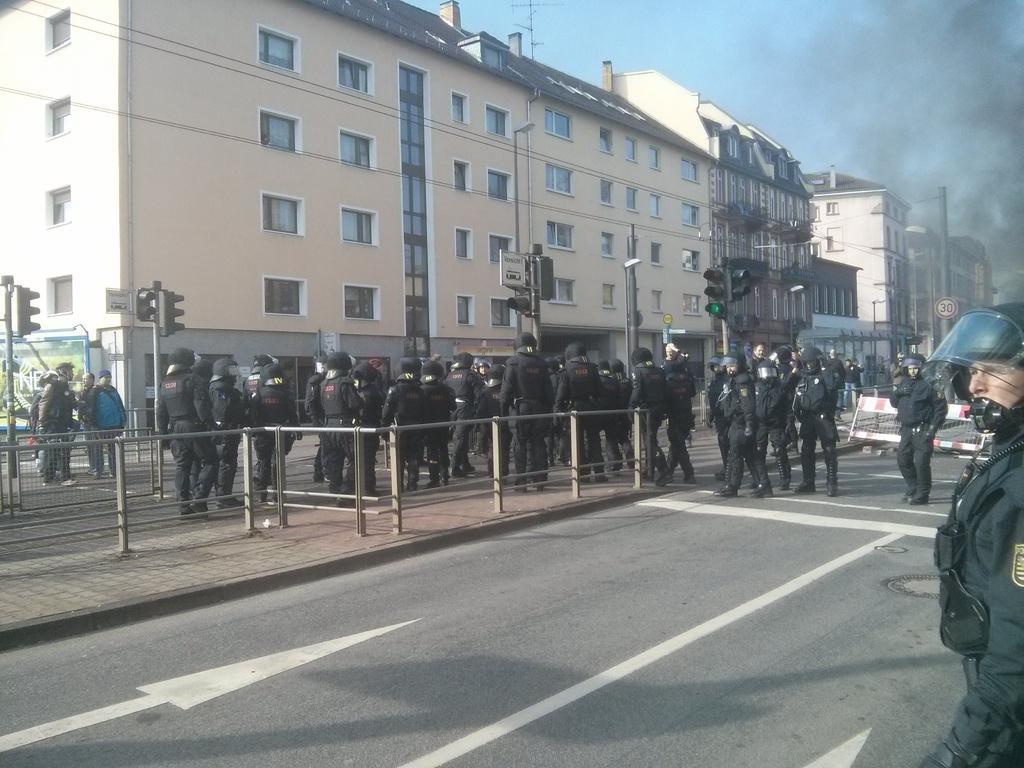Could you give a brief overview of what you see in this image? In this image on the road there are many people wearing uniform, helmets. On the road there are many traffic signals, sign boards, barricade. Here there is smoke. In the background there are buildings. The sky is clear. 